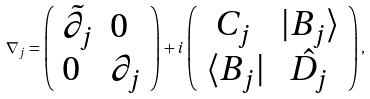Convert formula to latex. <formula><loc_0><loc_0><loc_500><loc_500>\nabla _ { j } = \left ( \begin{array} { l l } \tilde { \partial _ { j } } & 0 \\ 0 & \partial _ { j } \end{array} \right ) + i \left ( \begin{array} { l l } \ C _ { j } & | B _ { j } \rangle \\ \langle B _ { j } | & \ \hat { D _ { j } } \end{array} \right ) ,</formula> 